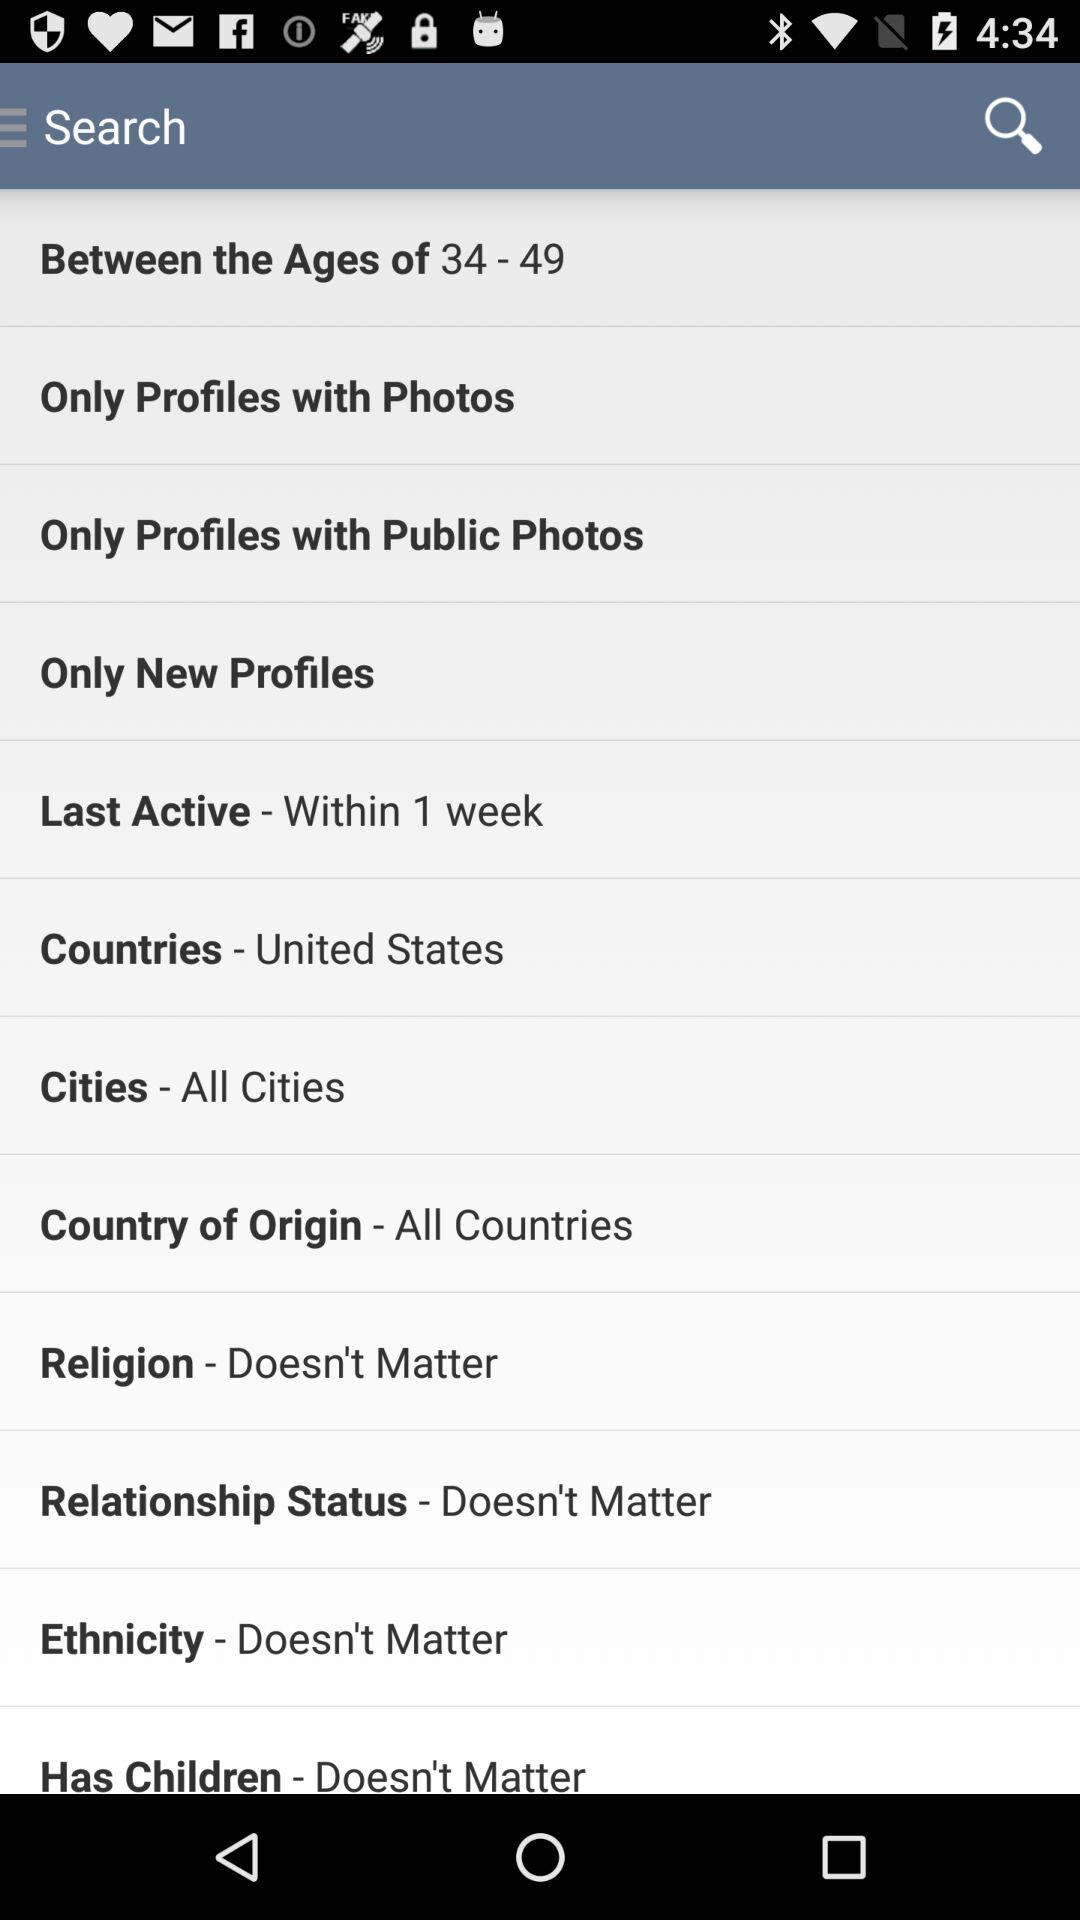What is the name of the country? The name of the country is the United States. 